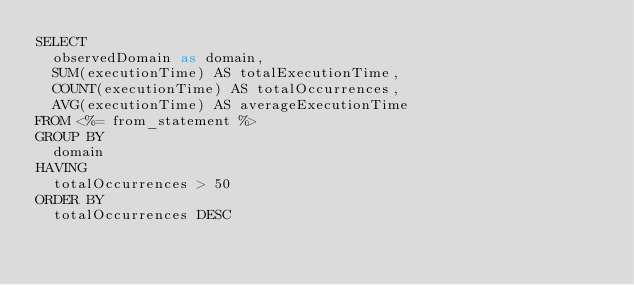<code> <loc_0><loc_0><loc_500><loc_500><_SQL_>SELECT
  observedDomain as domain,
  SUM(executionTime) AS totalExecutionTime,
  COUNT(executionTime) AS totalOccurrences,
  AVG(executionTime) AS averageExecutionTime
FROM <%= from_statement %>
GROUP BY
  domain
HAVING
  totalOccurrences > 50
ORDER BY
  totalOccurrences DESC
</code> 